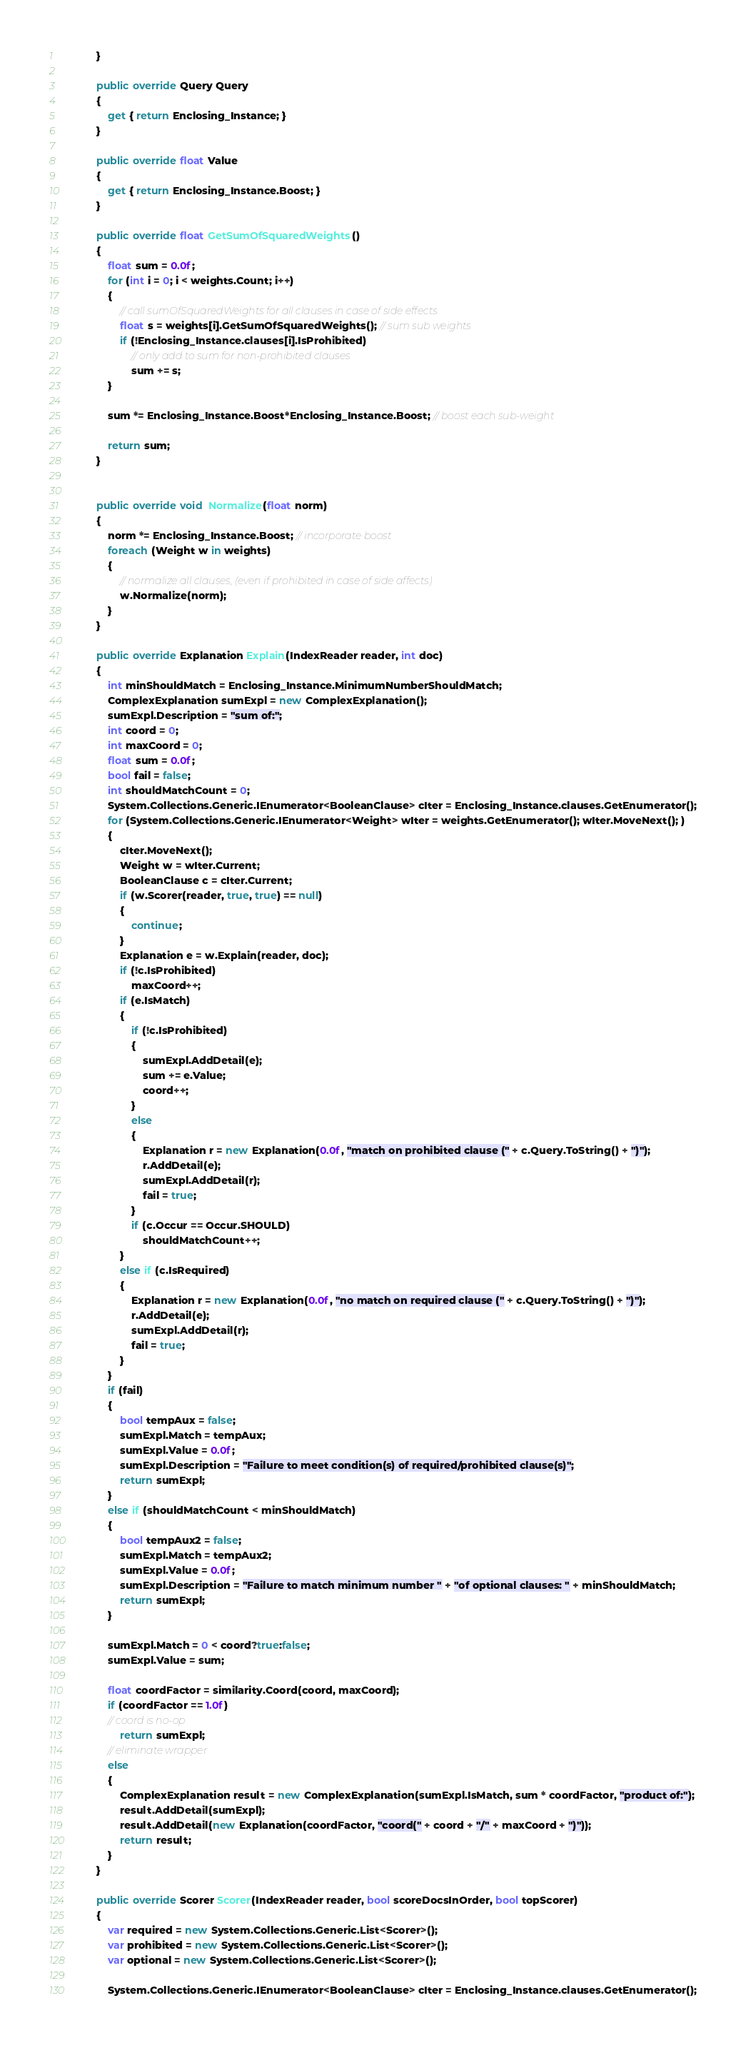Convert code to text. <code><loc_0><loc_0><loc_500><loc_500><_C#_>			}

		    public override Query Query
		    {
		        get { return Enclosing_Instance; }
		    }

		    public override float Value
		    {
		        get { return Enclosing_Instance.Boost; }
		    }

		    public override float GetSumOfSquaredWeights()
		    {
		        float sum = 0.0f;
		        for (int i = 0; i < weights.Count; i++)
		        {
		            // call sumOfSquaredWeights for all clauses in case of side effects
		            float s = weights[i].GetSumOfSquaredWeights(); // sum sub weights
                    if (!Enclosing_Instance.clauses[i].IsProhibited)
		                // only add to sum for non-prohibited clauses
		                sum += s;
		        }

		        sum *= Enclosing_Instance.Boost*Enclosing_Instance.Boost; // boost each sub-weight

		        return sum;
		    }


		    public override void  Normalize(float norm)
			{
				norm *= Enclosing_Instance.Boost; // incorporate boost
				foreach (Weight w in weights)
				{
					// normalize all clauses, (even if prohibited in case of side affects)
					w.Normalize(norm);
				}
			}
			
			public override Explanation Explain(IndexReader reader, int doc)
			{
				int minShouldMatch = Enclosing_Instance.MinimumNumberShouldMatch;
				ComplexExplanation sumExpl = new ComplexExplanation();
				sumExpl.Description = "sum of:";
				int coord = 0;
				int maxCoord = 0;
				float sum = 0.0f;
				bool fail = false;
				int shouldMatchCount = 0;
			    System.Collections.Generic.IEnumerator<BooleanClause> cIter = Enclosing_Instance.clauses.GetEnumerator();
				for (System.Collections.Generic.IEnumerator<Weight> wIter = weights.GetEnumerator(); wIter.MoveNext(); )
				{
                    cIter.MoveNext();
                    Weight w = wIter.Current;
					BooleanClause c = cIter.Current;
					if (w.Scorer(reader, true, true) == null)
					{
						continue;
					}
					Explanation e = w.Explain(reader, doc);
                    if (!c.IsProhibited)
						maxCoord++;
					if (e.IsMatch)
					{
                        if (!c.IsProhibited)
						{
							sumExpl.AddDetail(e);
							sum += e.Value;
							coord++;
						}
						else
						{
                            Explanation r = new Explanation(0.0f, "match on prohibited clause (" + c.Query.ToString() + ")");
							r.AddDetail(e);
							sumExpl.AddDetail(r);
							fail = true;
						}
						if (c.Occur == Occur.SHOULD)
							shouldMatchCount++;
					}
                    else if (c.IsRequired)
					{
                        Explanation r = new Explanation(0.0f, "no match on required clause (" + c.Query.ToString() + ")");
						r.AddDetail(e);
						sumExpl.AddDetail(r);
						fail = true;
					}
				}
				if (fail)
				{
					bool tempAux = false;
					sumExpl.Match = tempAux;
					sumExpl.Value = 0.0f;
					sumExpl.Description = "Failure to meet condition(s) of required/prohibited clause(s)";
					return sumExpl;
				}
				else if (shouldMatchCount < minShouldMatch)
				{
					bool tempAux2 = false;
					sumExpl.Match = tempAux2;
					sumExpl.Value = 0.0f;
					sumExpl.Description = "Failure to match minimum number " + "of optional clauses: " + minShouldMatch;
					return sumExpl;
				}
				
				sumExpl.Match = 0 < coord?true:false;
				sumExpl.Value = sum;
				
				float coordFactor = similarity.Coord(coord, maxCoord);
				if (coordFactor == 1.0f)
				// coord is no-op
					return sumExpl;
				// eliminate wrapper
				else
				{
					ComplexExplanation result = new ComplexExplanation(sumExpl.IsMatch, sum * coordFactor, "product of:");
					result.AddDetail(sumExpl);
					result.AddDetail(new Explanation(coordFactor, "coord(" + coord + "/" + maxCoord + ")"));
					return result;
				}
			}
			
			public override Scorer Scorer(IndexReader reader, bool scoreDocsInOrder, bool topScorer)
			{
				var required = new System.Collections.Generic.List<Scorer>();
                var prohibited = new System.Collections.Generic.List<Scorer>();
                var optional = new System.Collections.Generic.List<Scorer>();

			    System.Collections.Generic.IEnumerator<BooleanClause> cIter = Enclosing_Instance.clauses.GetEnumerator();</code> 